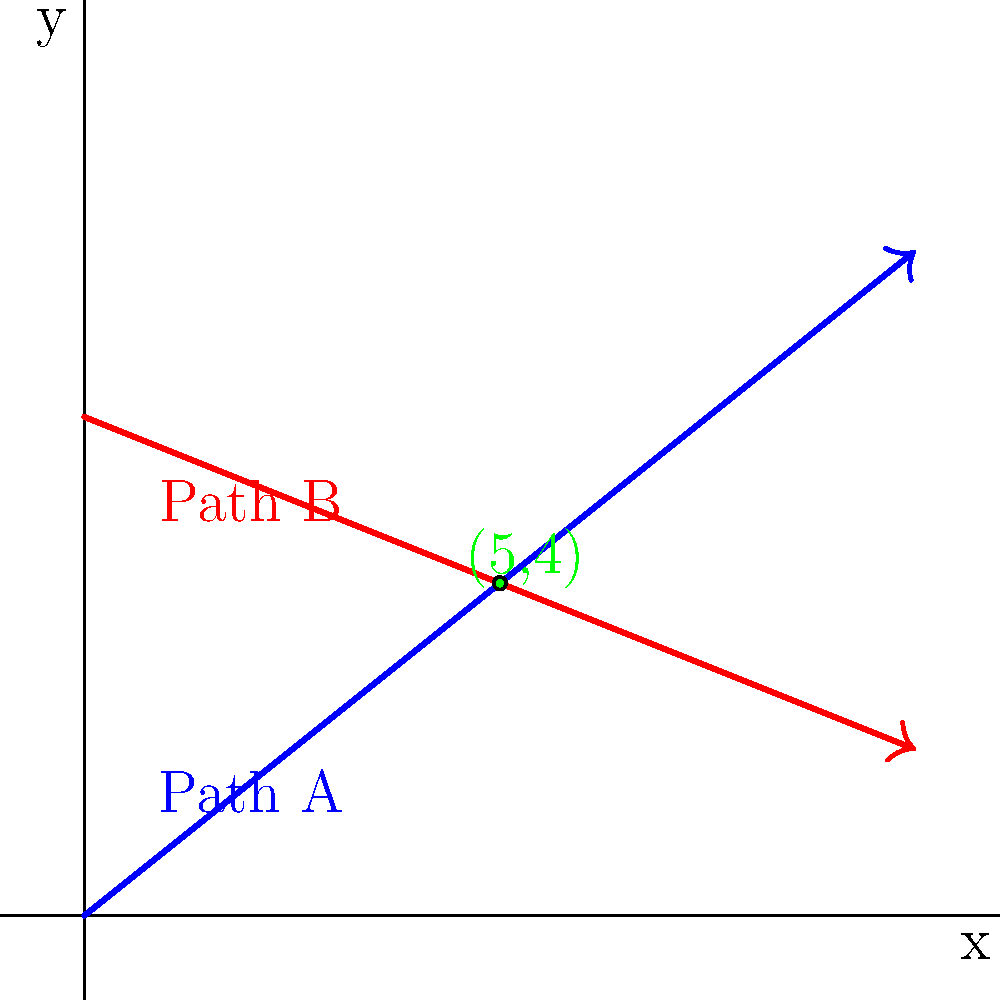Two aid workers are traveling along different paths in conflict zones. Worker A starts at point (0,0) and follows a straight path towards point (10,8). Worker B starts at point (0,6) and moves towards point (10,2). At what point do their paths intersect, and how far is this point from Worker A's starting position? Round your answer to the nearest whole number. Let's approach this step-by-step:

1) First, we need to find the equations of both paths.

   For Path A: $y = mx + b$
   Slope $m = (8-0)/(10-0) = 4/5$
   $y = (4/5)x + 0$

   For Path B: $y = mx + b$
   Slope $m = (2-6)/(10-0) = -2/5$
   $y = (-2/5)x + 6$

2) To find the intersection point, we set these equations equal to each other:

   $(4/5)x = (-2/5)x + 6$
   $(6/5)x = 6$
   $x = 5$

3) We can substitute this x-value into either equation to find y:

   $y = (4/5)(5) + 0 = 4$

   So, the intersection point is (5,4).

4) To find the distance from (0,0) to (5,4), we use the distance formula:

   $d = \sqrt{(x_2-x_1)^2 + (y_2-y_1)^2}$
   $d = \sqrt{(5-0)^2 + (4-0)^2}$
   $d = \sqrt{25 + 16} = \sqrt{41} \approx 6.40$

5) Rounding to the nearest whole number, we get 6.
Answer: (5,4), 6 units 